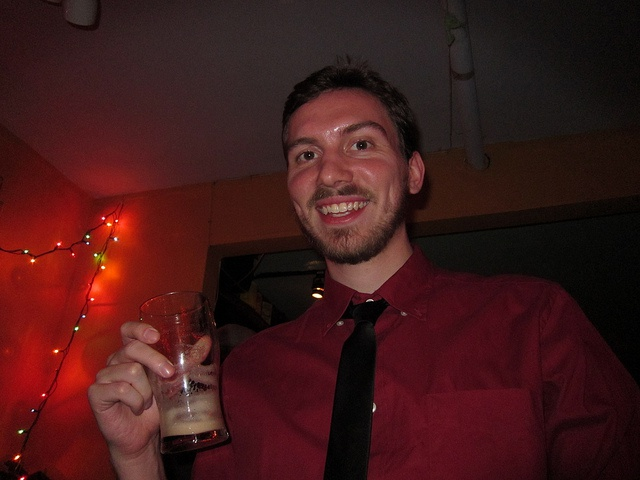Describe the objects in this image and their specific colors. I can see people in black, maroon, and brown tones, cup in black, maroon, brown, and gray tones, and tie in black, maroon, and gray tones in this image. 